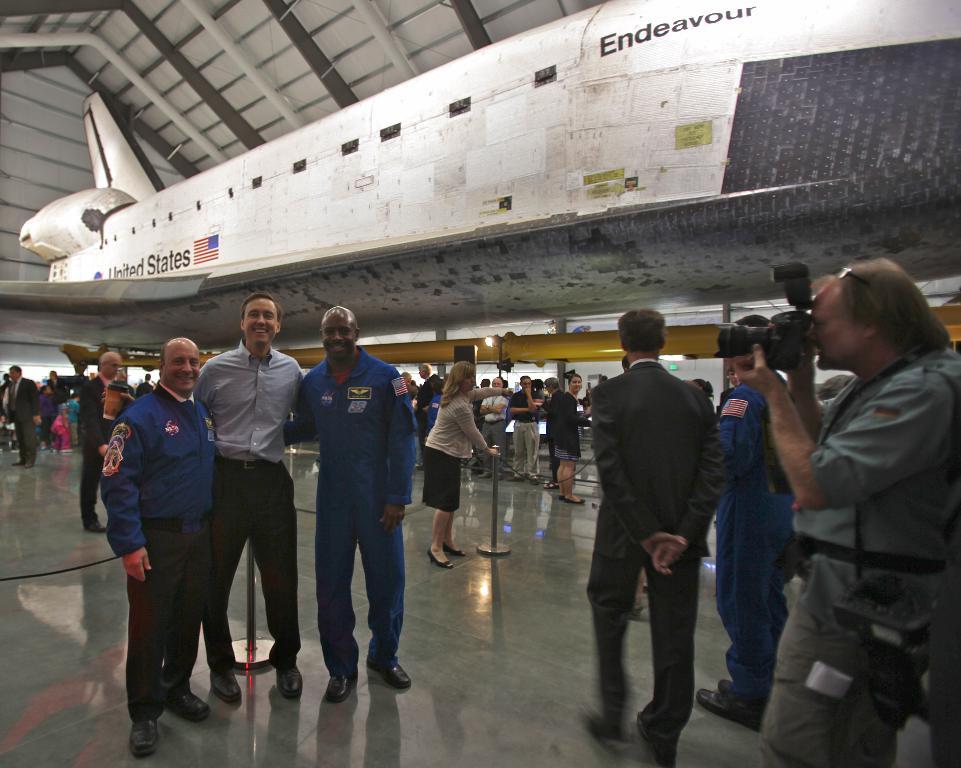What country is shown on this space shuttle?
Your response must be concise. United states. 